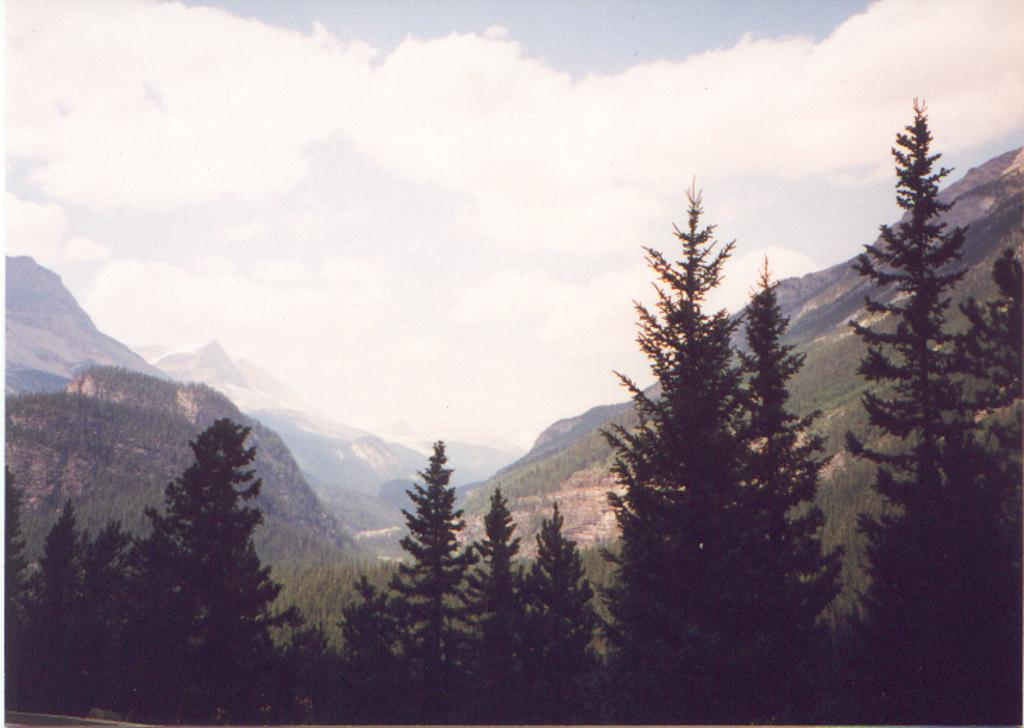What type of view is shown in the image? The image is an outside view. What can be seen at the bottom of the image? There are trees at the bottom of the image. What is visible in the background of the image? There are mountains visible in the background. What is visible at the top of the image? The sky is visible at the top of the image. What can be observed in the sky? Clouds are present in the sky. How many trucks are parked at the station in the image? There are no trucks or stations present in the image; it features an outside view with trees, mountains, and clouds. 